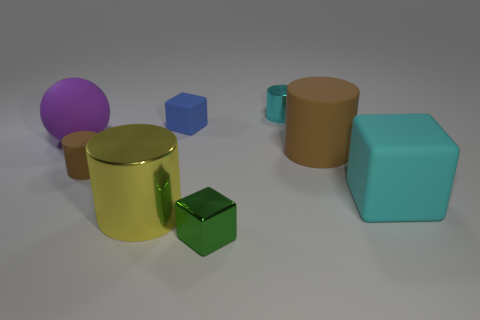Add 1 purple balls. How many objects exist? 9 Subtract all balls. How many objects are left? 7 Add 7 large yellow shiny cylinders. How many large yellow shiny cylinders are left? 8 Add 4 metal cylinders. How many metal cylinders exist? 6 Subtract 1 green cubes. How many objects are left? 7 Subtract all large brown shiny balls. Subtract all cyan matte things. How many objects are left? 7 